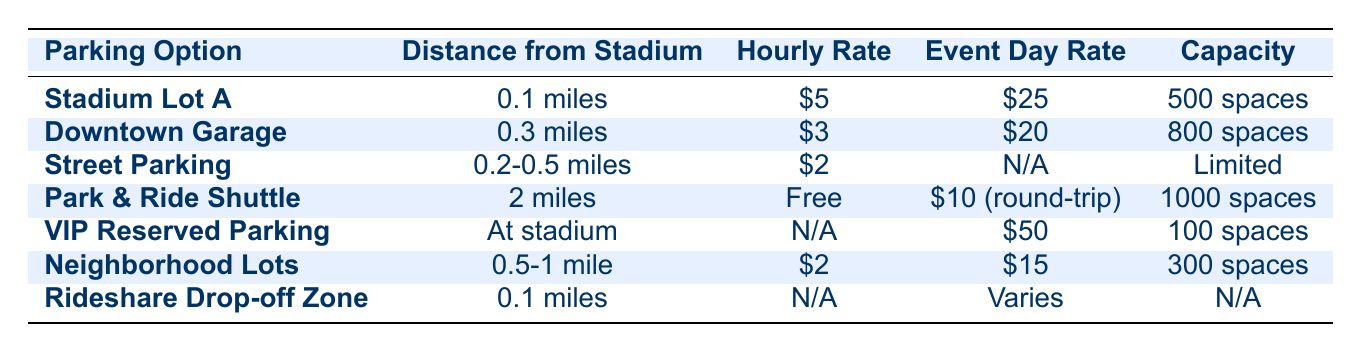What is the hourly rate for Stadium Lot A? According to the table, Stadium Lot A has an hourly rate listed as $5.
Answer: $5 How far is Downtown Garage from the stadium? The table indicates that Downtown Garage is 0.3 miles from the stadium.
Answer: 0.3 miles Is the event day rate for Street Parking available? The table shows that Street Parking has an event day rate listed as N/A, meaning it is not available.
Answer: No What is the total capacity of Parking Options that charge $2? The Parking Options charging $2 are Street Parking and Neighborhood Lots. Street Parking has a capacity of "Limited" (not numeric), while Neighborhood Lots have a capacity of 300 spaces. Since we cannot quantify "Limited," we only consider Neighborhood Lots' capacity, so the total capacity is 300.
Answer: 300 Which parking option has the highest event day rate? Looking at the event day rates in the table, VIP Reserved Parking has the highest rate of $50 compared to others, as its event day rate is distinctly higher than the rest.
Answer: $50 Are there any parking options with a distance of less than 0.2 miles from the stadium? The table shows that Stadium Lot A and Rideshare Drop-off Zone are both 0.1 miles from the stadium. Therefore, there are parking options closer than 0.2 miles.
Answer: Yes How much does the Park & Ride Shuttle cost for a round trip? The table lists the cost for Park & Ride Shuttle on an event day as $10 for a round trip, indicating that this is the cost to be paid for that service.
Answer: $10 If I were to park in the Neighborhood Lots, what would be my total cost if I park there for 4 hours? The hourly rate for Neighborhood Lots is $2. For 4 hours, the total would be calculated as 4 hours * $2/hour = $8.
Answer: $8 Which option offers the best capacity-to-cost ratio based on the event day rate? The best capacity-to-cost ratio can be calculated by looking at event day rates and the corresponding capacities. Notably, Downtown Garage has an event day rate of $20 for 800 spaces, leading to a ratio of 40 spaces per dollar. The calculation would then check which options yield the highest space per dollar value, where Downtown Garage emerges as favorable compared to other options that have lower capacity per their rate.
Answer: Downtown Garage 